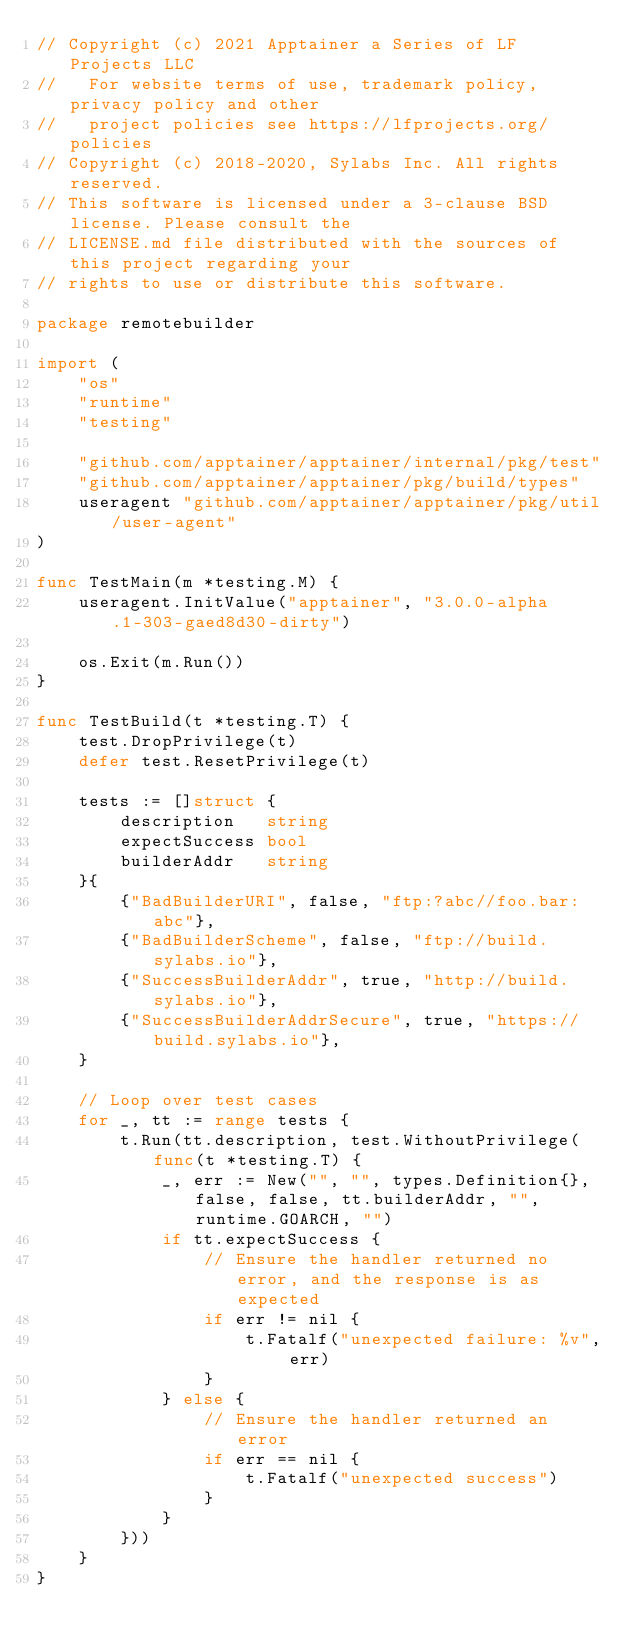<code> <loc_0><loc_0><loc_500><loc_500><_Go_>// Copyright (c) 2021 Apptainer a Series of LF Projects LLC
//   For website terms of use, trademark policy, privacy policy and other
//   project policies see https://lfprojects.org/policies
// Copyright (c) 2018-2020, Sylabs Inc. All rights reserved.
// This software is licensed under a 3-clause BSD license. Please consult the
// LICENSE.md file distributed with the sources of this project regarding your
// rights to use or distribute this software.

package remotebuilder

import (
	"os"
	"runtime"
	"testing"

	"github.com/apptainer/apptainer/internal/pkg/test"
	"github.com/apptainer/apptainer/pkg/build/types"
	useragent "github.com/apptainer/apptainer/pkg/util/user-agent"
)

func TestMain(m *testing.M) {
	useragent.InitValue("apptainer", "3.0.0-alpha.1-303-gaed8d30-dirty")

	os.Exit(m.Run())
}

func TestBuild(t *testing.T) {
	test.DropPrivilege(t)
	defer test.ResetPrivilege(t)

	tests := []struct {
		description   string
		expectSuccess bool
		builderAddr   string
	}{
		{"BadBuilderURI", false, "ftp:?abc//foo.bar:abc"},
		{"BadBuilderScheme", false, "ftp://build.sylabs.io"},
		{"SuccessBuilderAddr", true, "http://build.sylabs.io"},
		{"SuccessBuilderAddrSecure", true, "https://build.sylabs.io"},
	}

	// Loop over test cases
	for _, tt := range tests {
		t.Run(tt.description, test.WithoutPrivilege(func(t *testing.T) {
			_, err := New("", "", types.Definition{}, false, false, tt.builderAddr, "", runtime.GOARCH, "")
			if tt.expectSuccess {
				// Ensure the handler returned no error, and the response is as expected
				if err != nil {
					t.Fatalf("unexpected failure: %v", err)
				}
			} else {
				// Ensure the handler returned an error
				if err == nil {
					t.Fatalf("unexpected success")
				}
			}
		}))
	}
}
</code> 